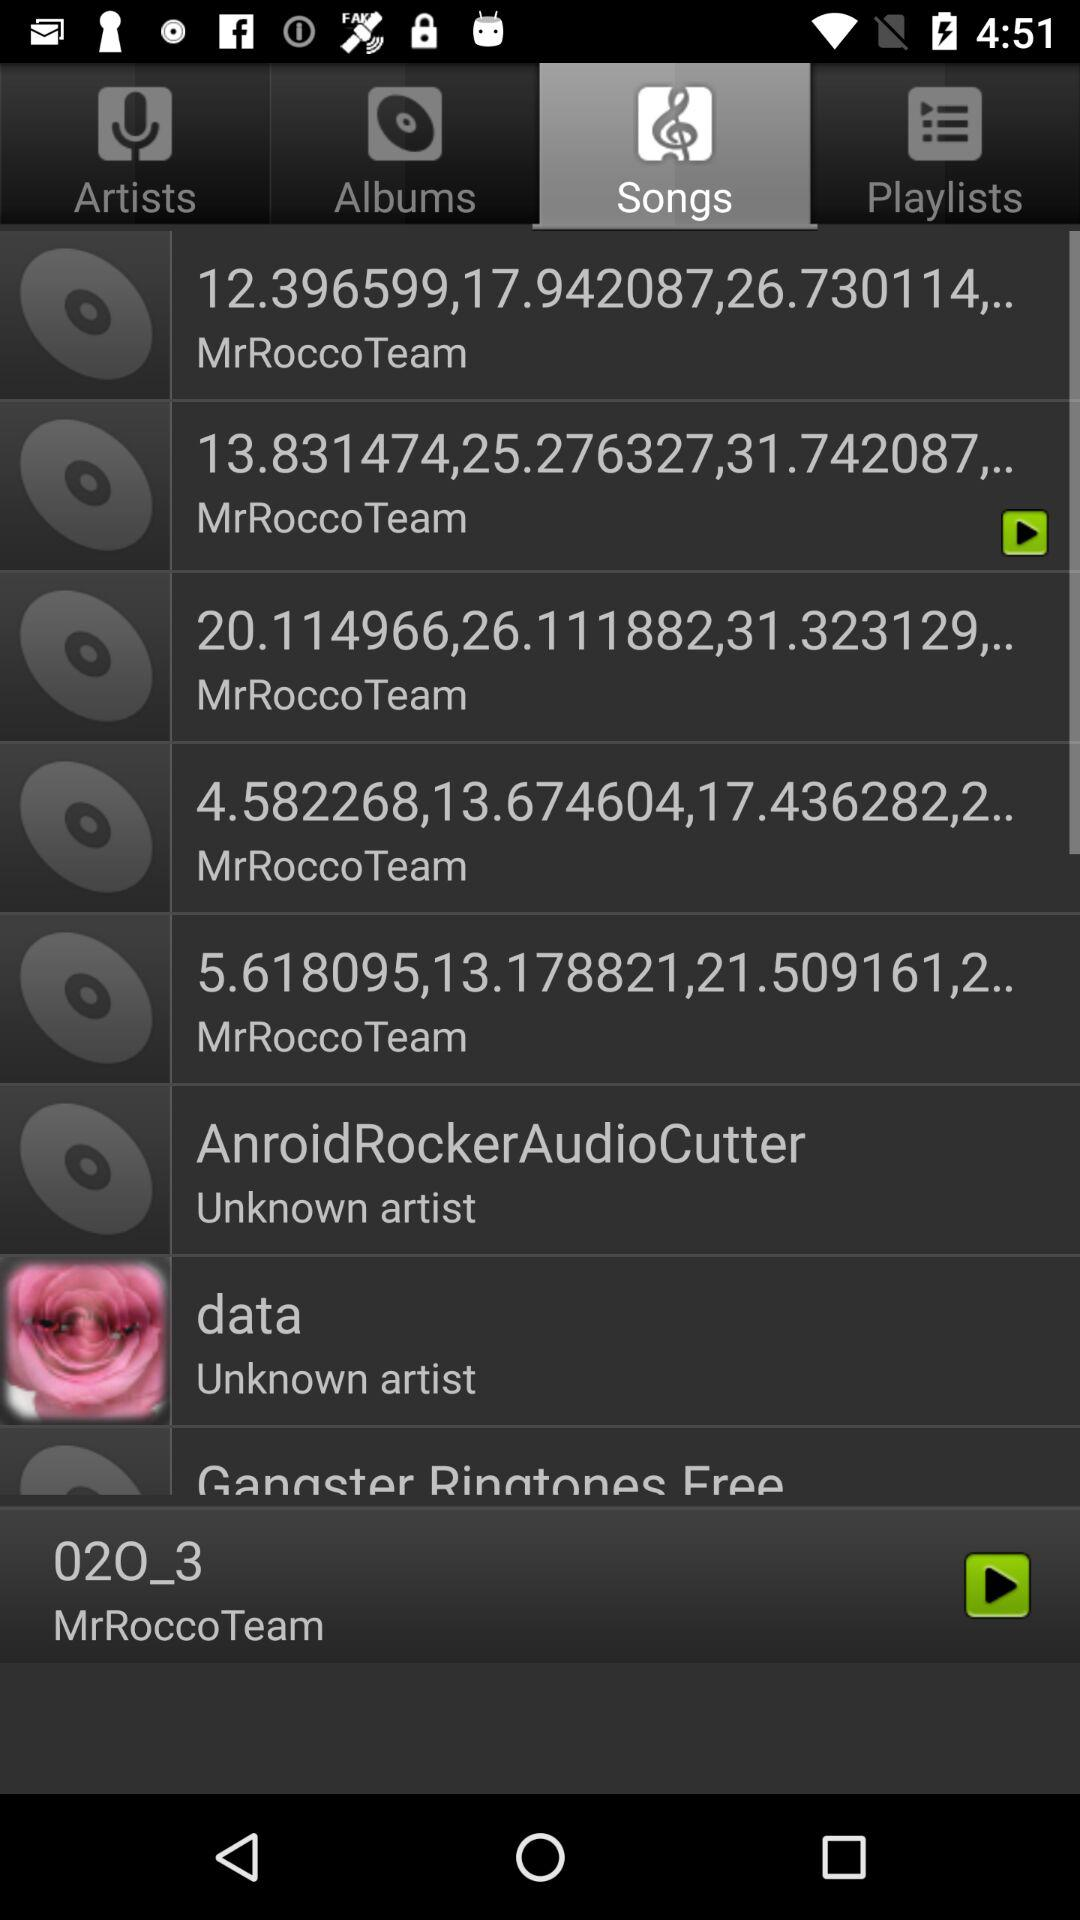What is the selected tab? The selected tab is "Songs". 